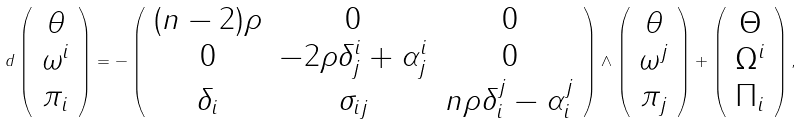Convert formula to latex. <formula><loc_0><loc_0><loc_500><loc_500>d \left ( \begin{array} { c } \theta \\ \omega ^ { i } \\ \pi _ { i } \end{array} \right ) = - \left ( \begin{array} { c c c } ( n - 2 ) \rho & 0 & 0 \\ 0 & - 2 \rho \delta ^ { i } _ { j } + \alpha ^ { i } _ { j } & 0 \\ \delta _ { i } & \sigma _ { i j } & n \rho \delta ^ { j } _ { i } - \alpha ^ { j } _ { i } \end{array} \right ) \wedge \left ( \begin{array} { c } \theta \\ \omega ^ { j } \\ \pi _ { j } \end{array} \right ) + \left ( \begin{array} { c } \Theta \\ \Omega ^ { i } \\ \Pi _ { i } \end{array} \right ) ,</formula> 